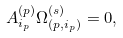<formula> <loc_0><loc_0><loc_500><loc_500>A ^ { ( p ) } _ { i _ { p } } \Omega ^ { ( s ) } _ { ( p , i _ { p } ) } = 0 ,</formula> 